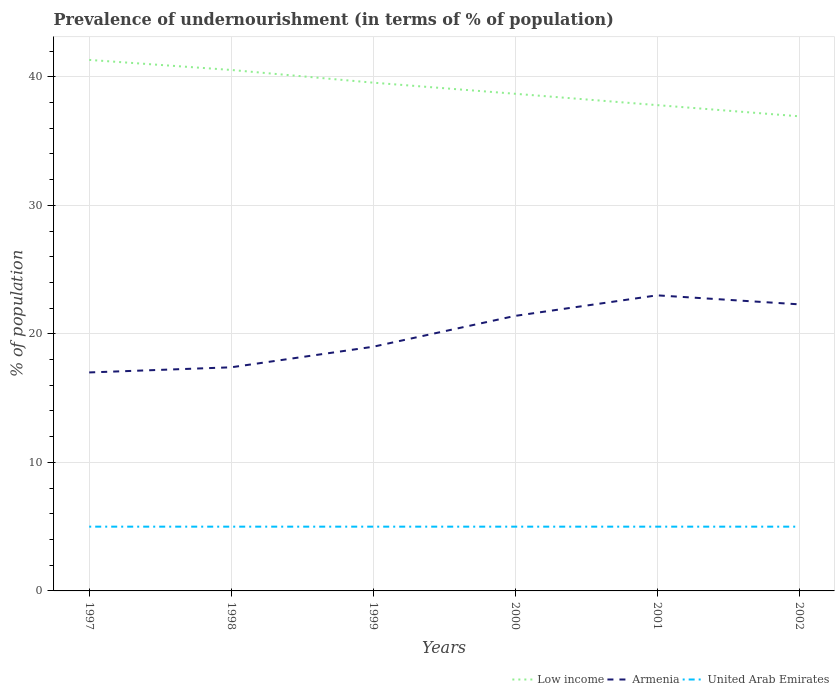How many different coloured lines are there?
Offer a very short reply. 3. Across all years, what is the maximum percentage of undernourished population in United Arab Emirates?
Your answer should be very brief. 5. Is the percentage of undernourished population in United Arab Emirates strictly greater than the percentage of undernourished population in Low income over the years?
Ensure brevity in your answer.  Yes. How many lines are there?
Keep it short and to the point. 3. Are the values on the major ticks of Y-axis written in scientific E-notation?
Give a very brief answer. No. Does the graph contain any zero values?
Your answer should be very brief. No. Where does the legend appear in the graph?
Your answer should be compact. Bottom right. What is the title of the graph?
Provide a succinct answer. Prevalence of undernourishment (in terms of % of population). What is the label or title of the Y-axis?
Offer a terse response. % of population. What is the % of population of Low income in 1997?
Offer a very short reply. 41.32. What is the % of population of Armenia in 1997?
Your answer should be very brief. 17. What is the % of population of Low income in 1998?
Offer a terse response. 40.54. What is the % of population in Armenia in 1998?
Give a very brief answer. 17.4. What is the % of population of United Arab Emirates in 1998?
Your answer should be very brief. 5. What is the % of population of Low income in 1999?
Your answer should be compact. 39.55. What is the % of population in Armenia in 1999?
Ensure brevity in your answer.  19. What is the % of population of United Arab Emirates in 1999?
Give a very brief answer. 5. What is the % of population in Low income in 2000?
Give a very brief answer. 38.68. What is the % of population of Armenia in 2000?
Make the answer very short. 21.4. What is the % of population of Low income in 2001?
Give a very brief answer. 37.8. What is the % of population in Armenia in 2001?
Offer a terse response. 23. What is the % of population in United Arab Emirates in 2001?
Make the answer very short. 5. What is the % of population in Low income in 2002?
Offer a very short reply. 36.93. What is the % of population in Armenia in 2002?
Provide a succinct answer. 22.3. Across all years, what is the maximum % of population in Low income?
Give a very brief answer. 41.32. Across all years, what is the maximum % of population of Armenia?
Keep it short and to the point. 23. Across all years, what is the maximum % of population in United Arab Emirates?
Ensure brevity in your answer.  5. Across all years, what is the minimum % of population of Low income?
Ensure brevity in your answer.  36.93. Across all years, what is the minimum % of population in United Arab Emirates?
Provide a succinct answer. 5. What is the total % of population of Low income in the graph?
Keep it short and to the point. 234.82. What is the total % of population in Armenia in the graph?
Offer a terse response. 120.1. What is the total % of population in United Arab Emirates in the graph?
Provide a succinct answer. 30. What is the difference between the % of population of Low income in 1997 and that in 1998?
Your answer should be compact. 0.78. What is the difference between the % of population of United Arab Emirates in 1997 and that in 1998?
Make the answer very short. 0. What is the difference between the % of population in Low income in 1997 and that in 1999?
Your response must be concise. 1.77. What is the difference between the % of population of Low income in 1997 and that in 2000?
Keep it short and to the point. 2.63. What is the difference between the % of population in Armenia in 1997 and that in 2000?
Keep it short and to the point. -4.4. What is the difference between the % of population in United Arab Emirates in 1997 and that in 2000?
Your answer should be very brief. 0. What is the difference between the % of population of Low income in 1997 and that in 2001?
Ensure brevity in your answer.  3.52. What is the difference between the % of population in Low income in 1997 and that in 2002?
Give a very brief answer. 4.39. What is the difference between the % of population in Armenia in 1997 and that in 2002?
Your response must be concise. -5.3. What is the difference between the % of population of Low income in 1998 and that in 1999?
Ensure brevity in your answer.  0.99. What is the difference between the % of population of Armenia in 1998 and that in 1999?
Provide a short and direct response. -1.6. What is the difference between the % of population of United Arab Emirates in 1998 and that in 1999?
Provide a short and direct response. 0. What is the difference between the % of population of Low income in 1998 and that in 2000?
Offer a terse response. 1.85. What is the difference between the % of population of Low income in 1998 and that in 2001?
Your answer should be compact. 2.74. What is the difference between the % of population of Armenia in 1998 and that in 2001?
Your answer should be very brief. -5.6. What is the difference between the % of population of United Arab Emirates in 1998 and that in 2001?
Your answer should be compact. 0. What is the difference between the % of population of Low income in 1998 and that in 2002?
Ensure brevity in your answer.  3.61. What is the difference between the % of population of Armenia in 1998 and that in 2002?
Provide a succinct answer. -4.9. What is the difference between the % of population in United Arab Emirates in 1998 and that in 2002?
Your answer should be very brief. 0. What is the difference between the % of population in Low income in 1999 and that in 2000?
Offer a very short reply. 0.86. What is the difference between the % of population in Armenia in 1999 and that in 2000?
Give a very brief answer. -2.4. What is the difference between the % of population in United Arab Emirates in 1999 and that in 2000?
Keep it short and to the point. 0. What is the difference between the % of population of Low income in 1999 and that in 2001?
Make the answer very short. 1.75. What is the difference between the % of population in United Arab Emirates in 1999 and that in 2001?
Ensure brevity in your answer.  0. What is the difference between the % of population in Low income in 1999 and that in 2002?
Offer a very short reply. 2.62. What is the difference between the % of population of Armenia in 1999 and that in 2002?
Ensure brevity in your answer.  -3.3. What is the difference between the % of population in Low income in 2000 and that in 2001?
Offer a terse response. 0.88. What is the difference between the % of population in United Arab Emirates in 2000 and that in 2001?
Ensure brevity in your answer.  0. What is the difference between the % of population of Low income in 2000 and that in 2002?
Make the answer very short. 1.75. What is the difference between the % of population of Armenia in 2000 and that in 2002?
Provide a succinct answer. -0.9. What is the difference between the % of population in Low income in 2001 and that in 2002?
Your response must be concise. 0.87. What is the difference between the % of population of Armenia in 2001 and that in 2002?
Provide a succinct answer. 0.7. What is the difference between the % of population of United Arab Emirates in 2001 and that in 2002?
Provide a succinct answer. 0. What is the difference between the % of population in Low income in 1997 and the % of population in Armenia in 1998?
Provide a succinct answer. 23.92. What is the difference between the % of population in Low income in 1997 and the % of population in United Arab Emirates in 1998?
Offer a terse response. 36.32. What is the difference between the % of population in Low income in 1997 and the % of population in Armenia in 1999?
Ensure brevity in your answer.  22.32. What is the difference between the % of population in Low income in 1997 and the % of population in United Arab Emirates in 1999?
Ensure brevity in your answer.  36.32. What is the difference between the % of population in Armenia in 1997 and the % of population in United Arab Emirates in 1999?
Your answer should be compact. 12. What is the difference between the % of population of Low income in 1997 and the % of population of Armenia in 2000?
Your answer should be very brief. 19.92. What is the difference between the % of population of Low income in 1997 and the % of population of United Arab Emirates in 2000?
Ensure brevity in your answer.  36.32. What is the difference between the % of population of Armenia in 1997 and the % of population of United Arab Emirates in 2000?
Provide a succinct answer. 12. What is the difference between the % of population in Low income in 1997 and the % of population in Armenia in 2001?
Keep it short and to the point. 18.32. What is the difference between the % of population of Low income in 1997 and the % of population of United Arab Emirates in 2001?
Offer a very short reply. 36.32. What is the difference between the % of population in Armenia in 1997 and the % of population in United Arab Emirates in 2001?
Your answer should be very brief. 12. What is the difference between the % of population in Low income in 1997 and the % of population in Armenia in 2002?
Make the answer very short. 19.02. What is the difference between the % of population in Low income in 1997 and the % of population in United Arab Emirates in 2002?
Keep it short and to the point. 36.32. What is the difference between the % of population in Low income in 1998 and the % of population in Armenia in 1999?
Your answer should be compact. 21.54. What is the difference between the % of population in Low income in 1998 and the % of population in United Arab Emirates in 1999?
Give a very brief answer. 35.54. What is the difference between the % of population in Low income in 1998 and the % of population in Armenia in 2000?
Keep it short and to the point. 19.14. What is the difference between the % of population in Low income in 1998 and the % of population in United Arab Emirates in 2000?
Offer a very short reply. 35.54. What is the difference between the % of population in Low income in 1998 and the % of population in Armenia in 2001?
Your answer should be very brief. 17.54. What is the difference between the % of population in Low income in 1998 and the % of population in United Arab Emirates in 2001?
Make the answer very short. 35.54. What is the difference between the % of population in Low income in 1998 and the % of population in Armenia in 2002?
Offer a terse response. 18.24. What is the difference between the % of population of Low income in 1998 and the % of population of United Arab Emirates in 2002?
Make the answer very short. 35.54. What is the difference between the % of population of Armenia in 1998 and the % of population of United Arab Emirates in 2002?
Make the answer very short. 12.4. What is the difference between the % of population of Low income in 1999 and the % of population of Armenia in 2000?
Make the answer very short. 18.15. What is the difference between the % of population of Low income in 1999 and the % of population of United Arab Emirates in 2000?
Your response must be concise. 34.55. What is the difference between the % of population of Low income in 1999 and the % of population of Armenia in 2001?
Provide a succinct answer. 16.55. What is the difference between the % of population of Low income in 1999 and the % of population of United Arab Emirates in 2001?
Your response must be concise. 34.55. What is the difference between the % of population in Armenia in 1999 and the % of population in United Arab Emirates in 2001?
Give a very brief answer. 14. What is the difference between the % of population in Low income in 1999 and the % of population in Armenia in 2002?
Offer a terse response. 17.25. What is the difference between the % of population in Low income in 1999 and the % of population in United Arab Emirates in 2002?
Provide a short and direct response. 34.55. What is the difference between the % of population of Armenia in 1999 and the % of population of United Arab Emirates in 2002?
Provide a succinct answer. 14. What is the difference between the % of population in Low income in 2000 and the % of population in Armenia in 2001?
Your answer should be compact. 15.68. What is the difference between the % of population in Low income in 2000 and the % of population in United Arab Emirates in 2001?
Your answer should be compact. 33.68. What is the difference between the % of population of Armenia in 2000 and the % of population of United Arab Emirates in 2001?
Make the answer very short. 16.4. What is the difference between the % of population of Low income in 2000 and the % of population of Armenia in 2002?
Offer a very short reply. 16.38. What is the difference between the % of population in Low income in 2000 and the % of population in United Arab Emirates in 2002?
Ensure brevity in your answer.  33.68. What is the difference between the % of population of Low income in 2001 and the % of population of Armenia in 2002?
Offer a very short reply. 15.5. What is the difference between the % of population in Low income in 2001 and the % of population in United Arab Emirates in 2002?
Provide a short and direct response. 32.8. What is the average % of population of Low income per year?
Your answer should be very brief. 39.14. What is the average % of population in Armenia per year?
Provide a succinct answer. 20.02. What is the average % of population of United Arab Emirates per year?
Provide a succinct answer. 5. In the year 1997, what is the difference between the % of population in Low income and % of population in Armenia?
Offer a terse response. 24.32. In the year 1997, what is the difference between the % of population of Low income and % of population of United Arab Emirates?
Ensure brevity in your answer.  36.32. In the year 1998, what is the difference between the % of population in Low income and % of population in Armenia?
Give a very brief answer. 23.14. In the year 1998, what is the difference between the % of population in Low income and % of population in United Arab Emirates?
Make the answer very short. 35.54. In the year 1999, what is the difference between the % of population of Low income and % of population of Armenia?
Offer a very short reply. 20.55. In the year 1999, what is the difference between the % of population in Low income and % of population in United Arab Emirates?
Your response must be concise. 34.55. In the year 1999, what is the difference between the % of population of Armenia and % of population of United Arab Emirates?
Provide a short and direct response. 14. In the year 2000, what is the difference between the % of population in Low income and % of population in Armenia?
Provide a short and direct response. 17.28. In the year 2000, what is the difference between the % of population in Low income and % of population in United Arab Emirates?
Provide a succinct answer. 33.68. In the year 2001, what is the difference between the % of population of Low income and % of population of Armenia?
Provide a succinct answer. 14.8. In the year 2001, what is the difference between the % of population of Low income and % of population of United Arab Emirates?
Your answer should be compact. 32.8. In the year 2002, what is the difference between the % of population of Low income and % of population of Armenia?
Ensure brevity in your answer.  14.63. In the year 2002, what is the difference between the % of population of Low income and % of population of United Arab Emirates?
Offer a very short reply. 31.93. What is the ratio of the % of population in Low income in 1997 to that in 1998?
Make the answer very short. 1.02. What is the ratio of the % of population of Armenia in 1997 to that in 1998?
Offer a terse response. 0.98. What is the ratio of the % of population of Low income in 1997 to that in 1999?
Provide a short and direct response. 1.04. What is the ratio of the % of population of Armenia in 1997 to that in 1999?
Your answer should be very brief. 0.89. What is the ratio of the % of population of Low income in 1997 to that in 2000?
Provide a succinct answer. 1.07. What is the ratio of the % of population of Armenia in 1997 to that in 2000?
Your response must be concise. 0.79. What is the ratio of the % of population in Low income in 1997 to that in 2001?
Your response must be concise. 1.09. What is the ratio of the % of population in Armenia in 1997 to that in 2001?
Ensure brevity in your answer.  0.74. What is the ratio of the % of population in United Arab Emirates in 1997 to that in 2001?
Give a very brief answer. 1. What is the ratio of the % of population in Low income in 1997 to that in 2002?
Keep it short and to the point. 1.12. What is the ratio of the % of population of Armenia in 1997 to that in 2002?
Your answer should be compact. 0.76. What is the ratio of the % of population in Low income in 1998 to that in 1999?
Give a very brief answer. 1.02. What is the ratio of the % of population of Armenia in 1998 to that in 1999?
Your answer should be compact. 0.92. What is the ratio of the % of population in Low income in 1998 to that in 2000?
Give a very brief answer. 1.05. What is the ratio of the % of population in Armenia in 1998 to that in 2000?
Provide a short and direct response. 0.81. What is the ratio of the % of population of United Arab Emirates in 1998 to that in 2000?
Your answer should be very brief. 1. What is the ratio of the % of population in Low income in 1998 to that in 2001?
Offer a very short reply. 1.07. What is the ratio of the % of population in Armenia in 1998 to that in 2001?
Your answer should be compact. 0.76. What is the ratio of the % of population of United Arab Emirates in 1998 to that in 2001?
Your response must be concise. 1. What is the ratio of the % of population of Low income in 1998 to that in 2002?
Provide a short and direct response. 1.1. What is the ratio of the % of population of Armenia in 1998 to that in 2002?
Your response must be concise. 0.78. What is the ratio of the % of population in Low income in 1999 to that in 2000?
Offer a terse response. 1.02. What is the ratio of the % of population of Armenia in 1999 to that in 2000?
Offer a terse response. 0.89. What is the ratio of the % of population in United Arab Emirates in 1999 to that in 2000?
Give a very brief answer. 1. What is the ratio of the % of population of Low income in 1999 to that in 2001?
Provide a short and direct response. 1.05. What is the ratio of the % of population of Armenia in 1999 to that in 2001?
Make the answer very short. 0.83. What is the ratio of the % of population of United Arab Emirates in 1999 to that in 2001?
Offer a terse response. 1. What is the ratio of the % of population of Low income in 1999 to that in 2002?
Make the answer very short. 1.07. What is the ratio of the % of population of Armenia in 1999 to that in 2002?
Give a very brief answer. 0.85. What is the ratio of the % of population in United Arab Emirates in 1999 to that in 2002?
Give a very brief answer. 1. What is the ratio of the % of population in Low income in 2000 to that in 2001?
Provide a succinct answer. 1.02. What is the ratio of the % of population of Armenia in 2000 to that in 2001?
Your answer should be compact. 0.93. What is the ratio of the % of population of United Arab Emirates in 2000 to that in 2001?
Provide a short and direct response. 1. What is the ratio of the % of population in Low income in 2000 to that in 2002?
Your response must be concise. 1.05. What is the ratio of the % of population of Armenia in 2000 to that in 2002?
Offer a terse response. 0.96. What is the ratio of the % of population of Low income in 2001 to that in 2002?
Your answer should be compact. 1.02. What is the ratio of the % of population of Armenia in 2001 to that in 2002?
Make the answer very short. 1.03. What is the ratio of the % of population in United Arab Emirates in 2001 to that in 2002?
Your answer should be compact. 1. What is the difference between the highest and the second highest % of population of Low income?
Ensure brevity in your answer.  0.78. What is the difference between the highest and the second highest % of population in United Arab Emirates?
Provide a short and direct response. 0. What is the difference between the highest and the lowest % of population of Low income?
Make the answer very short. 4.39. What is the difference between the highest and the lowest % of population of Armenia?
Give a very brief answer. 6. What is the difference between the highest and the lowest % of population in United Arab Emirates?
Your answer should be compact. 0. 